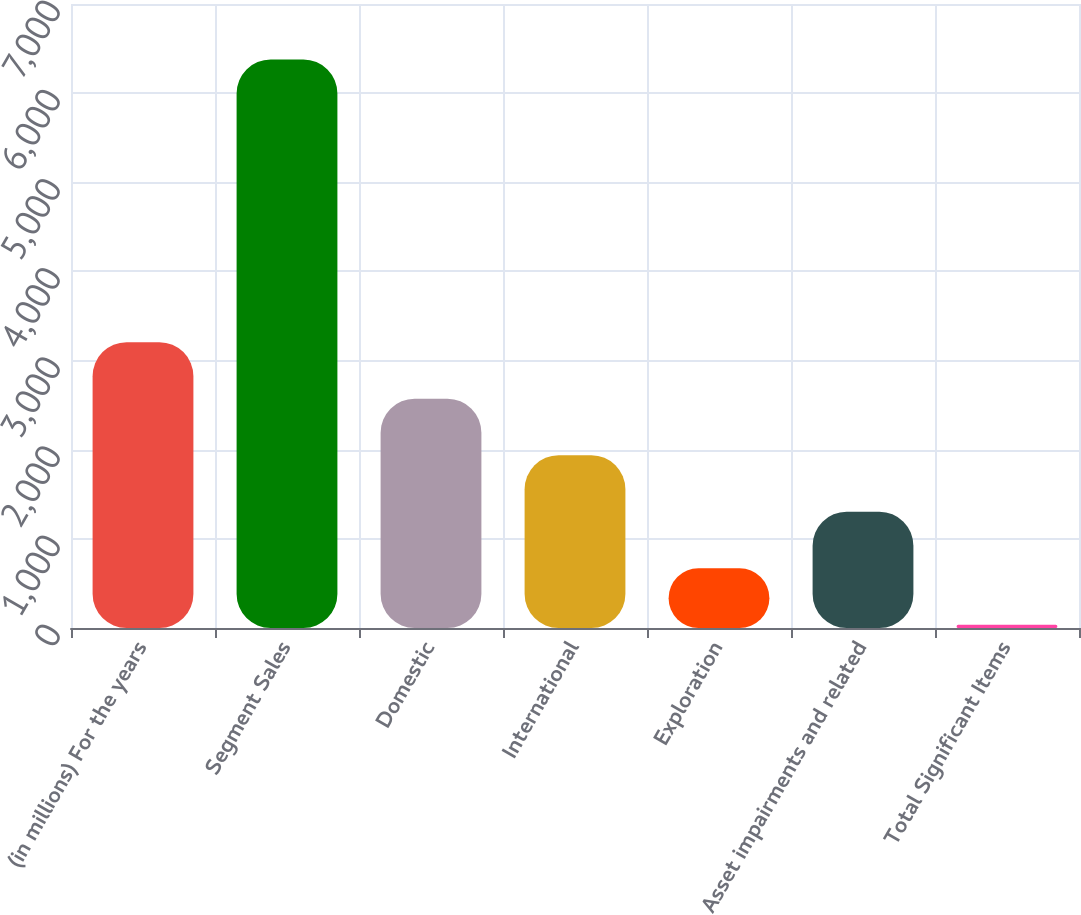Convert chart to OTSL. <chart><loc_0><loc_0><loc_500><loc_500><bar_chart><fcel>(in millions) For the years<fcel>Segment Sales<fcel>Domestic<fcel>International<fcel>Exploration<fcel>Asset impairments and related<fcel>Total Significant Items<nl><fcel>3206.5<fcel>6377<fcel>2572.4<fcel>1938.3<fcel>670.1<fcel>1304.2<fcel>36<nl></chart> 